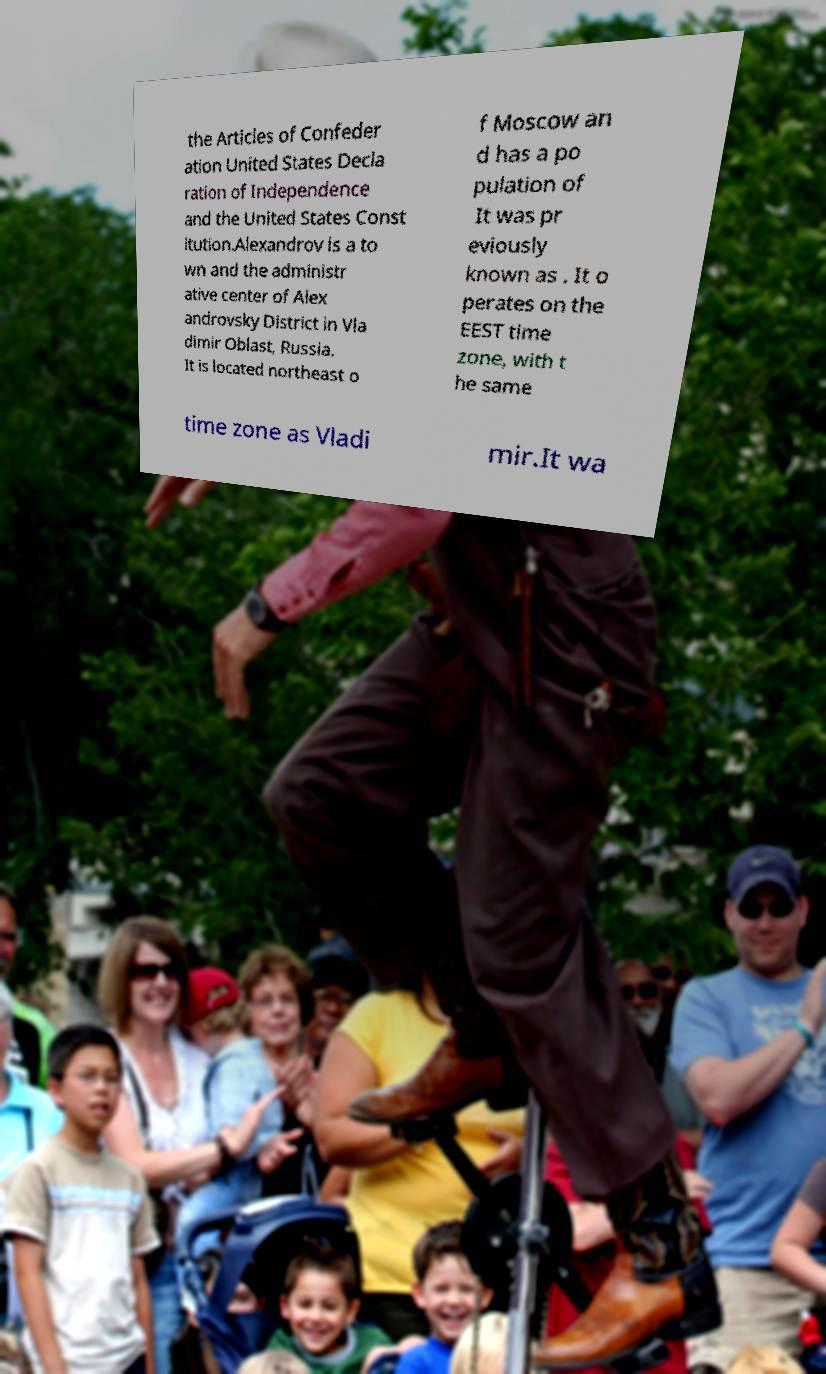Please read and relay the text visible in this image. What does it say? the Articles of Confeder ation United States Decla ration of Independence and the United States Const itution.Alexandrov is a to wn and the administr ative center of Alex androvsky District in Vla dimir Oblast, Russia. It is located northeast o f Moscow an d has a po pulation of It was pr eviously known as . It o perates on the EEST time zone, with t he same time zone as Vladi mir.It wa 